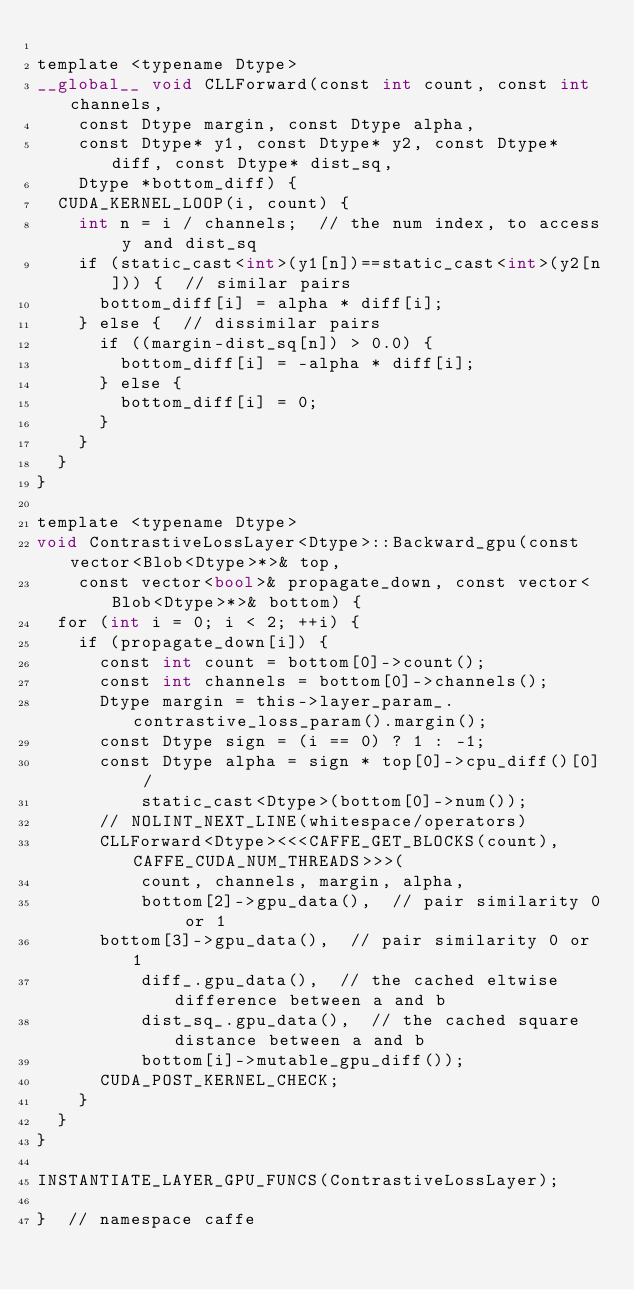<code> <loc_0><loc_0><loc_500><loc_500><_Cuda_>
template <typename Dtype>
__global__ void CLLForward(const int count, const int channels,
    const Dtype margin, const Dtype alpha,
    const Dtype* y1, const Dtype* y2, const Dtype* diff, const Dtype* dist_sq,
    Dtype *bottom_diff) {
  CUDA_KERNEL_LOOP(i, count) {
    int n = i / channels;  // the num index, to access y and dist_sq
    if (static_cast<int>(y1[n])==static_cast<int>(y2[n])) {  // similar pairs
      bottom_diff[i] = alpha * diff[i];
    } else {  // dissimilar pairs
      if ((margin-dist_sq[n]) > 0.0) {
        bottom_diff[i] = -alpha * diff[i];
      } else {
        bottom_diff[i] = 0;
      }
    }
  }
}

template <typename Dtype>
void ContrastiveLossLayer<Dtype>::Backward_gpu(const vector<Blob<Dtype>*>& top,
    const vector<bool>& propagate_down, const vector<Blob<Dtype>*>& bottom) {
  for (int i = 0; i < 2; ++i) {
    if (propagate_down[i]) {
      const int count = bottom[0]->count();
      const int channels = bottom[0]->channels();
      Dtype margin = this->layer_param_.contrastive_loss_param().margin();
      const Dtype sign = (i == 0) ? 1 : -1;
      const Dtype alpha = sign * top[0]->cpu_diff()[0] /
          static_cast<Dtype>(bottom[0]->num());
      // NOLINT_NEXT_LINE(whitespace/operators)
      CLLForward<Dtype><<<CAFFE_GET_BLOCKS(count), CAFFE_CUDA_NUM_THREADS>>>(
          count, channels, margin, alpha,
          bottom[2]->gpu_data(),  // pair similarity 0 or 1
		  bottom[3]->gpu_data(),  // pair similarity 0 or 1
          diff_.gpu_data(),  // the cached eltwise difference between a and b
          dist_sq_.gpu_data(),  // the cached square distance between a and b
          bottom[i]->mutable_gpu_diff());
      CUDA_POST_KERNEL_CHECK;
    }
  }
}

INSTANTIATE_LAYER_GPU_FUNCS(ContrastiveLossLayer);

}  // namespace caffe
</code> 